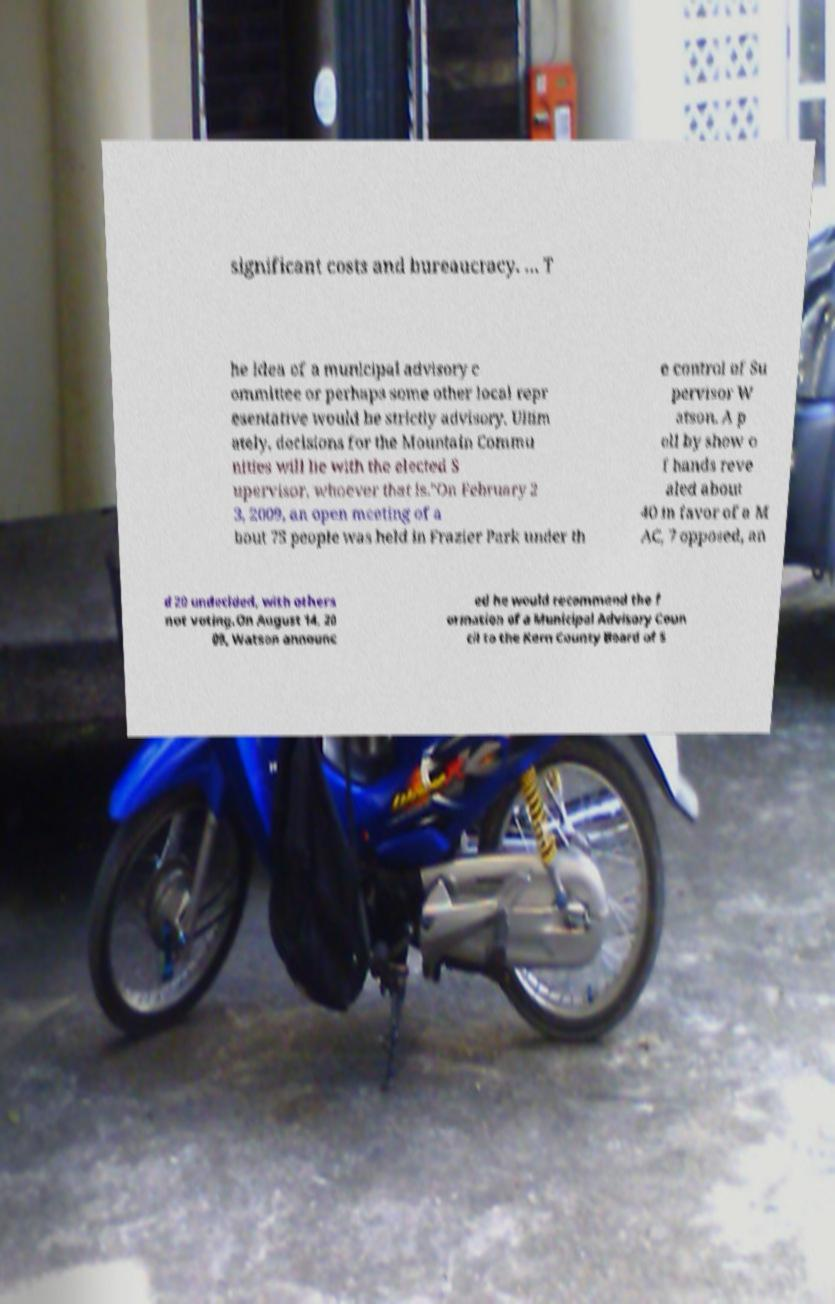For documentation purposes, I need the text within this image transcribed. Could you provide that? significant costs and bureaucracy. … T he idea of a municipal advisory c ommittee or perhaps some other local repr esentative would be strictly advisory. Ultim ately, decisions for the Mountain Commu nities will lie with the elected S upervisor, whoever that is."On February 2 3, 2009, an open meeting of a bout 75 people was held in Frazier Park under th e control of Su pervisor W atson. A p oll by show o f hands reve aled about 40 in favor of a M AC, 7 opposed, an d 20 undecided, with others not voting.On August 14, 20 09, Watson announc ed he would recommend the f ormation of a Municipal Advisory Coun cil to the Kern County Board of S 